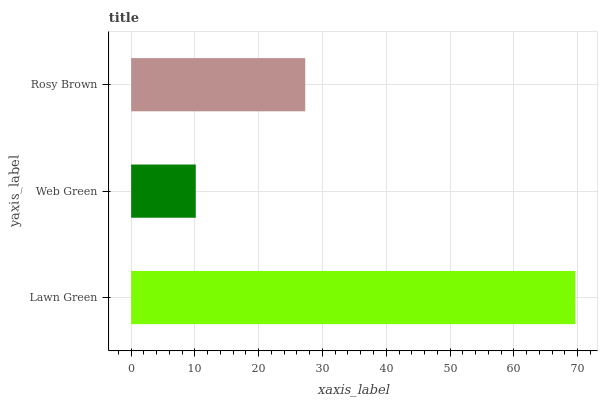Is Web Green the minimum?
Answer yes or no. Yes. Is Lawn Green the maximum?
Answer yes or no. Yes. Is Rosy Brown the minimum?
Answer yes or no. No. Is Rosy Brown the maximum?
Answer yes or no. No. Is Rosy Brown greater than Web Green?
Answer yes or no. Yes. Is Web Green less than Rosy Brown?
Answer yes or no. Yes. Is Web Green greater than Rosy Brown?
Answer yes or no. No. Is Rosy Brown less than Web Green?
Answer yes or no. No. Is Rosy Brown the high median?
Answer yes or no. Yes. Is Rosy Brown the low median?
Answer yes or no. Yes. Is Web Green the high median?
Answer yes or no. No. Is Web Green the low median?
Answer yes or no. No. 